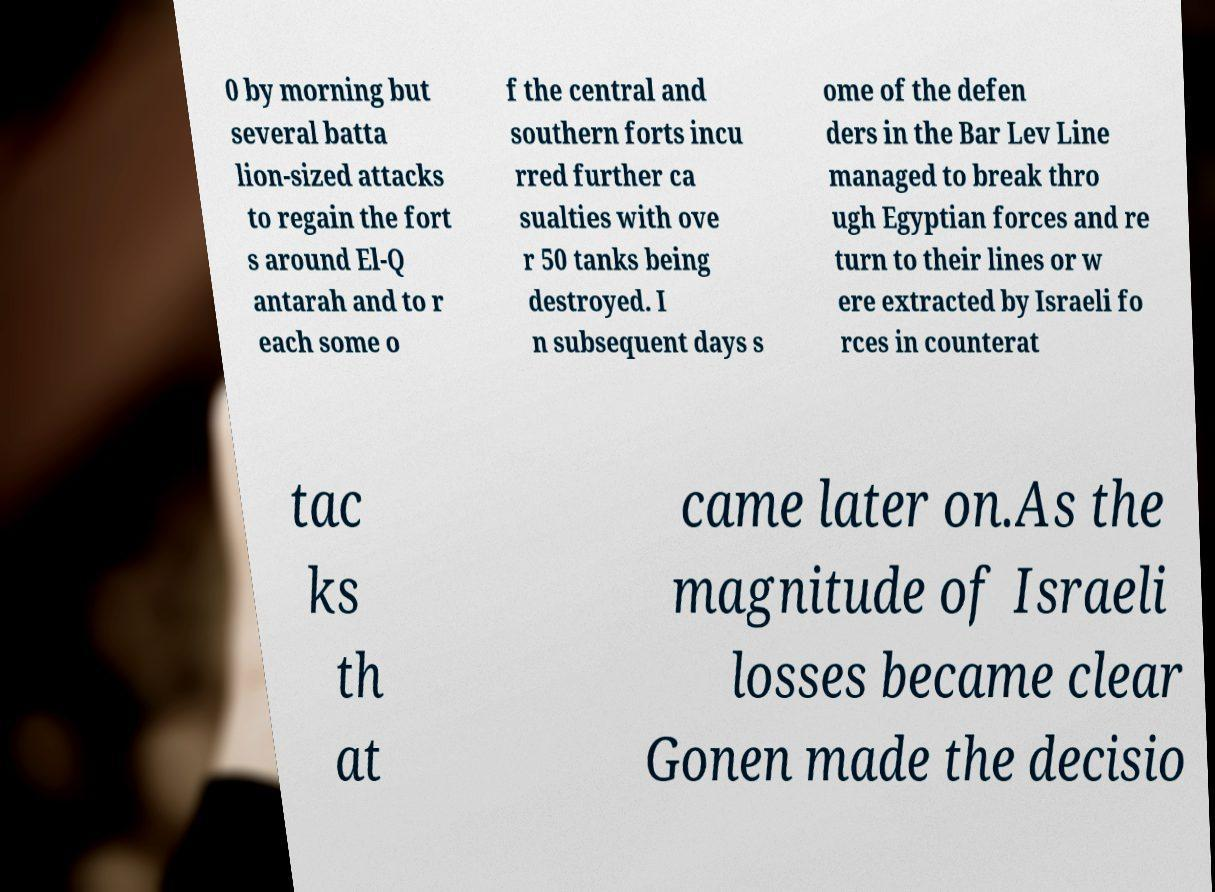What messages or text are displayed in this image? I need them in a readable, typed format. 0 by morning but several batta lion-sized attacks to regain the fort s around El-Q antarah and to r each some o f the central and southern forts incu rred further ca sualties with ove r 50 tanks being destroyed. I n subsequent days s ome of the defen ders in the Bar Lev Line managed to break thro ugh Egyptian forces and re turn to their lines or w ere extracted by Israeli fo rces in counterat tac ks th at came later on.As the magnitude of Israeli losses became clear Gonen made the decisio 